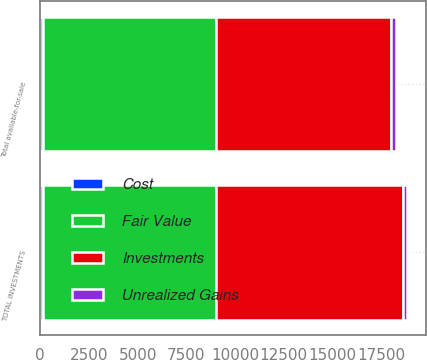Convert chart to OTSL. <chart><loc_0><loc_0><loc_500><loc_500><stacked_bar_chart><ecel><fcel>Total available-for-sale<fcel>TOTAL INVESTMENTS<nl><fcel>Investments<fcel>9008<fcel>9597<nl><fcel>Cost<fcel>127<fcel>127<nl><fcel>Unrealized Gains<fcel>246<fcel>246<nl><fcel>Fair Value<fcel>8889<fcel>8889<nl></chart> 